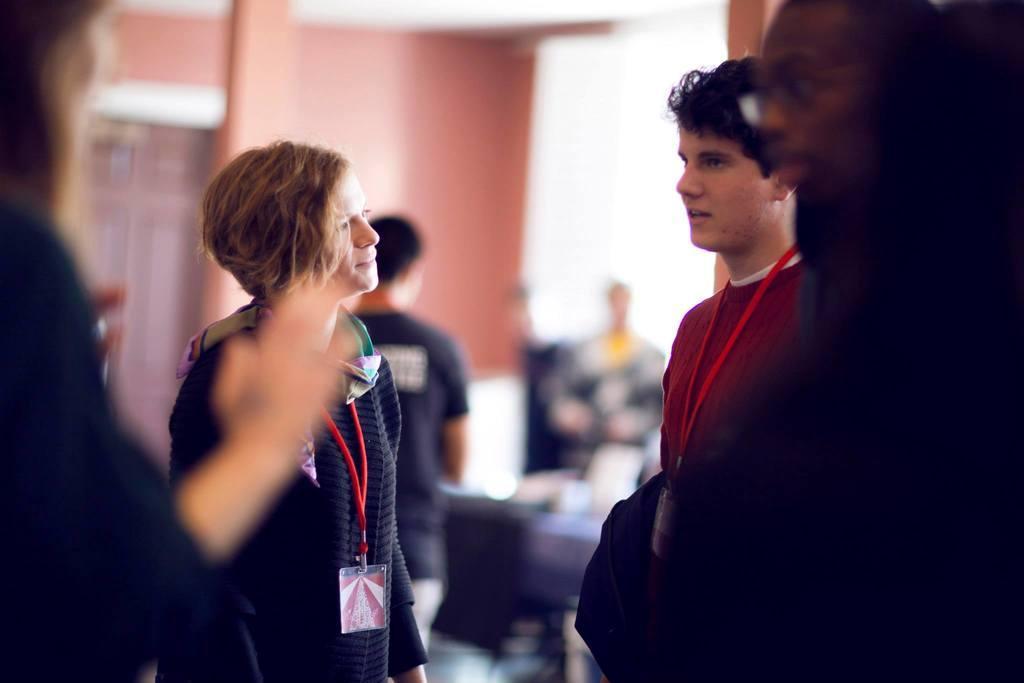Could you give a brief overview of what you see in this image? In this picture I can see people are standing among them some are wearing an ID card. In the background I can see a wall and some other object. The background of the image is blurred. 